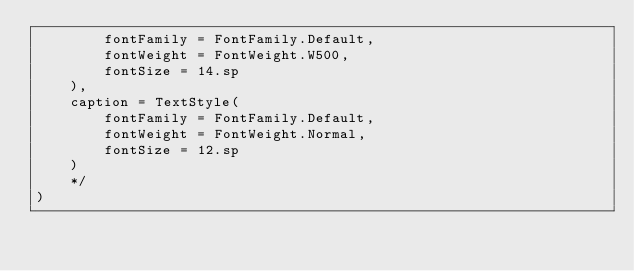Convert code to text. <code><loc_0><loc_0><loc_500><loc_500><_Kotlin_>        fontFamily = FontFamily.Default,
        fontWeight = FontWeight.W500,
        fontSize = 14.sp
    ),
    caption = TextStyle(
        fontFamily = FontFamily.Default,
        fontWeight = FontWeight.Normal,
        fontSize = 12.sp
    )
    */
)</code> 